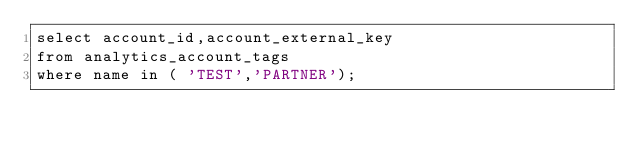Convert code to text. <code><loc_0><loc_0><loc_500><loc_500><_SQL_>select account_id,account_external_key
from analytics_account_tags
where name in ( 'TEST','PARTNER');
</code> 